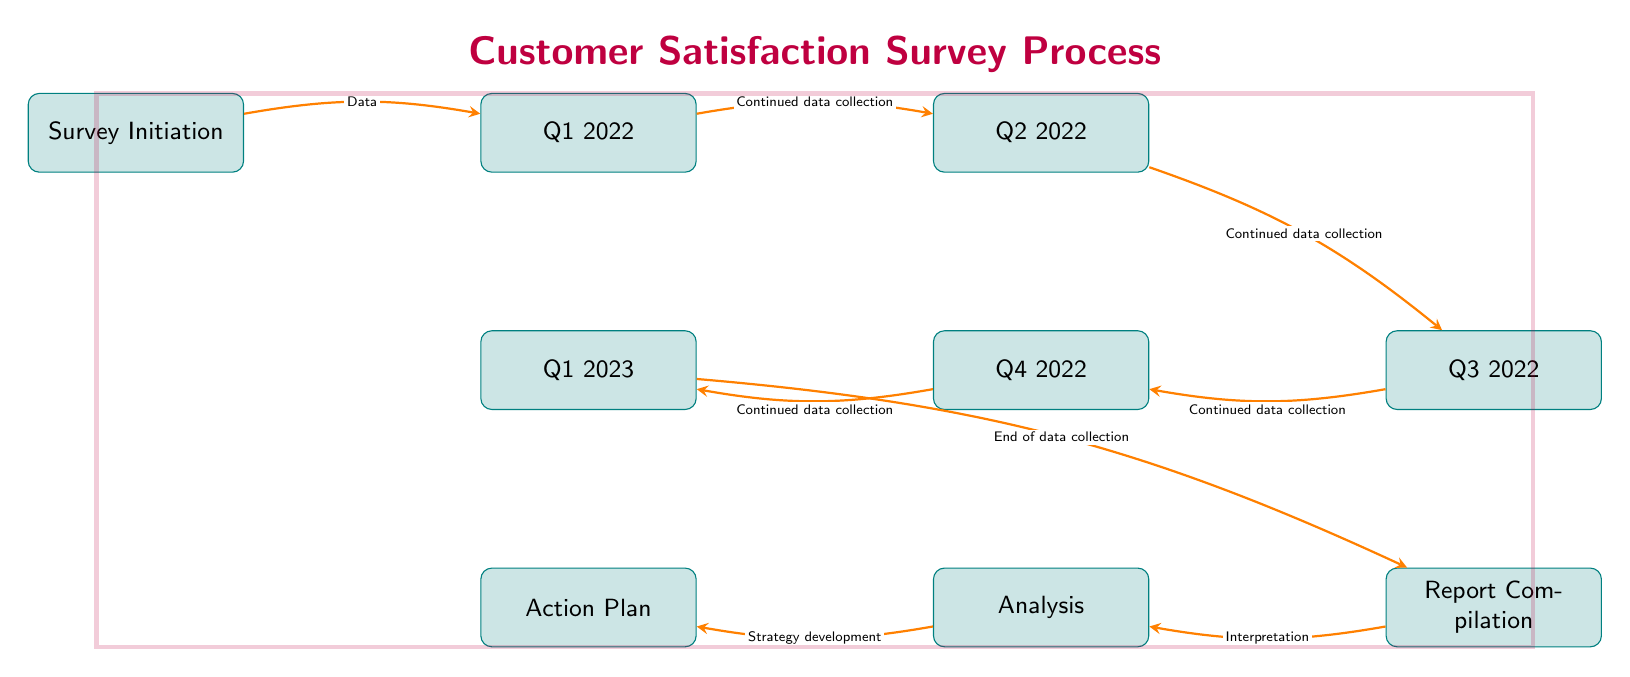What is the first node in the diagram? The first node in the diagram is labeled "Survey Initiation," which indicates the starting point of the customer satisfaction survey process.
Answer: Survey Initiation How many nodes are displayed in the diagram? By counting the nodes, we can identify that there are a total of 9 nodes in the diagram, including labels from the survey initiation to the action plan.
Answer: 9 What is the last milestone in the survey process? The last milestone in the survey process is the "Action Plan," which represents the outcome of the survey analysis and strategy development.
Answer: Action Plan What type of relationship connects "Q3 2022" and "Q4 2022"? The relationship between "Q3 2022" and "Q4 2022" is characterized as "Continued data collection," indicating that the process of gathering data continues between these two quarters.
Answer: Continued data collection What does the arrow from "Report Compilation" to "Analysis" signify? The arrow signifies a directional flow where the "Report Compilation" leads to "Analysis," meaning that once the data is compiled, it undergoes interpretation for further analysis.
Answer: Interpretation How many edges are present in the diagram? We can determine that there are a total of 8 edges connecting the nodes in the diagram, which represent the flow of the survey process from initiation to action plan.
Answer: 8 What does the color of the nodes represent in the diagram? The color teal for the nodes suggests that they are all part of the same category or process related to the customer satisfaction survey, making it easy to identify them visually as related milestones.
Answer: Teal What does the overall theme of the diagram represent? The overall theme of the diagram is "Customer Satisfaction Survey Process," which indicates that the diagram outlines the steps involved in conducting and analyzing a customer satisfaction survey for small business owners.
Answer: Customer Satisfaction Survey Process What is the primary outcome of the diagram? The primary outcome of the diagram is the "Action Plan," which summarizes the strategies developed from the analysis of survey data to enhance customer satisfaction among small business owners.
Answer: Action Plan 